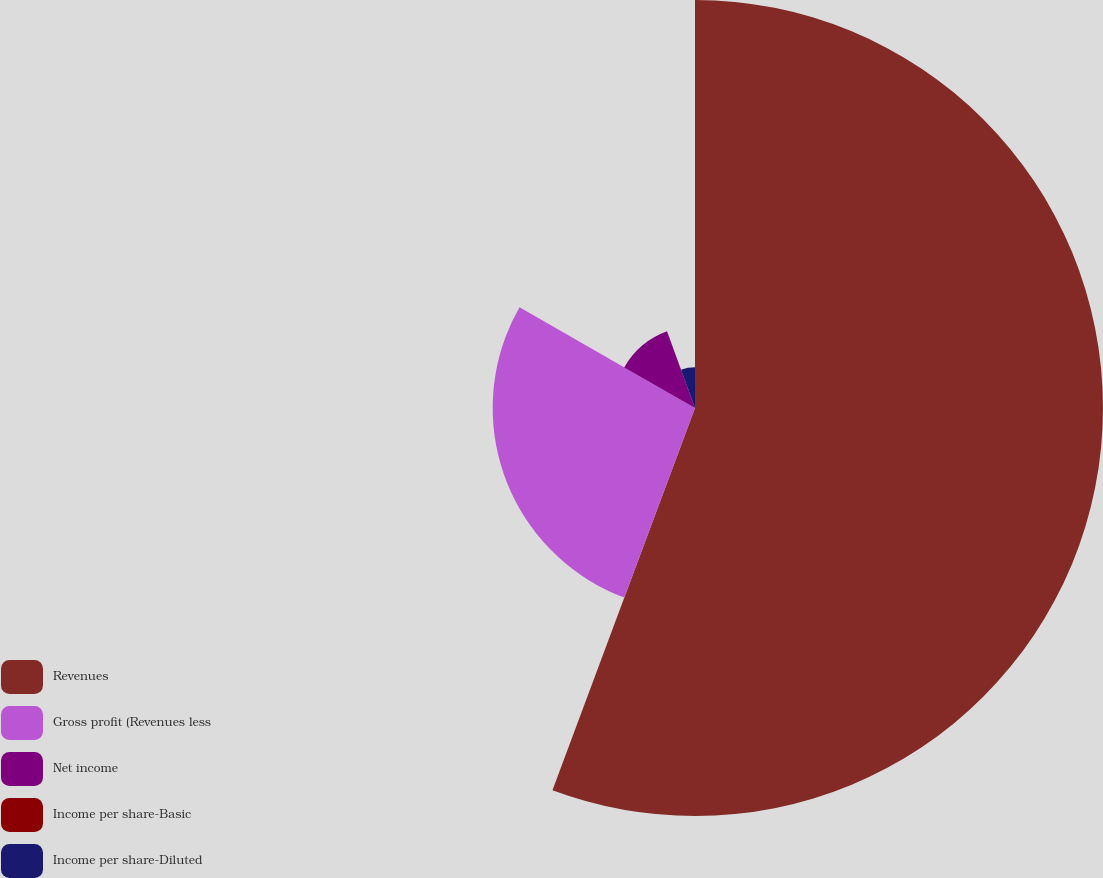Convert chart to OTSL. <chart><loc_0><loc_0><loc_500><loc_500><pie_chart><fcel>Revenues<fcel>Gross profit (Revenues less<fcel>Net income<fcel>Income per share-Basic<fcel>Income per share-Diluted<nl><fcel>55.68%<fcel>27.61%<fcel>11.14%<fcel>0.0%<fcel>5.57%<nl></chart> 